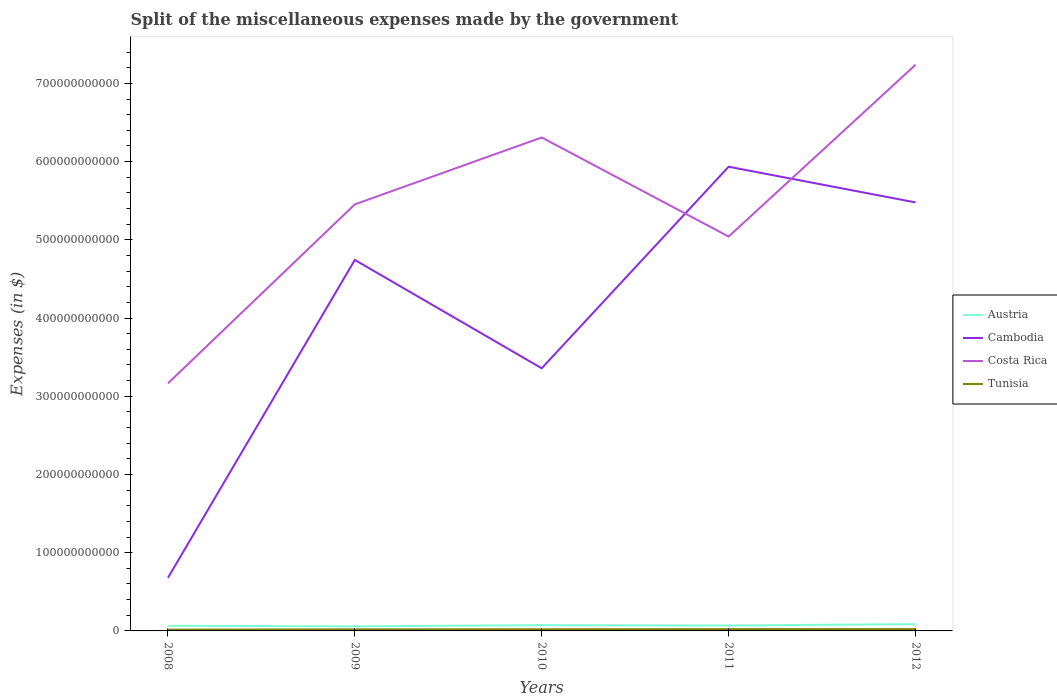Does the line corresponding to Austria intersect with the line corresponding to Tunisia?
Provide a succinct answer. No. Across all years, what is the maximum miscellaneous expenses made by the government in Costa Rica?
Ensure brevity in your answer.  3.16e+11. In which year was the miscellaneous expenses made by the government in Cambodia maximum?
Keep it short and to the point. 2008. What is the total miscellaneous expenses made by the government in Austria in the graph?
Make the answer very short. -4.32e+08. What is the difference between the highest and the second highest miscellaneous expenses made by the government in Tunisia?
Provide a short and direct response. 6.82e+08. What is the difference between the highest and the lowest miscellaneous expenses made by the government in Austria?
Provide a succinct answer. 2. How many lines are there?
Give a very brief answer. 4. How many years are there in the graph?
Give a very brief answer. 5. What is the difference between two consecutive major ticks on the Y-axis?
Your response must be concise. 1.00e+11. Does the graph contain any zero values?
Your response must be concise. No. How many legend labels are there?
Keep it short and to the point. 4. How are the legend labels stacked?
Give a very brief answer. Vertical. What is the title of the graph?
Offer a very short reply. Split of the miscellaneous expenses made by the government. What is the label or title of the Y-axis?
Your response must be concise. Expenses (in $). What is the Expenses (in $) of Austria in 2008?
Your response must be concise. 6.52e+09. What is the Expenses (in $) of Cambodia in 2008?
Make the answer very short. 6.78e+1. What is the Expenses (in $) of Costa Rica in 2008?
Offer a terse response. 3.16e+11. What is the Expenses (in $) of Tunisia in 2008?
Make the answer very short. 1.64e+09. What is the Expenses (in $) of Austria in 2009?
Ensure brevity in your answer.  5.87e+09. What is the Expenses (in $) of Cambodia in 2009?
Give a very brief answer. 4.74e+11. What is the Expenses (in $) in Costa Rica in 2009?
Make the answer very short. 5.45e+11. What is the Expenses (in $) of Tunisia in 2009?
Provide a succinct answer. 2.00e+09. What is the Expenses (in $) of Austria in 2010?
Your response must be concise. 7.39e+09. What is the Expenses (in $) of Cambodia in 2010?
Keep it short and to the point. 3.36e+11. What is the Expenses (in $) of Costa Rica in 2010?
Provide a succinct answer. 6.31e+11. What is the Expenses (in $) of Tunisia in 2010?
Make the answer very short. 2.07e+09. What is the Expenses (in $) in Austria in 2011?
Your answer should be compact. 6.96e+09. What is the Expenses (in $) in Cambodia in 2011?
Provide a succinct answer. 5.93e+11. What is the Expenses (in $) in Costa Rica in 2011?
Ensure brevity in your answer.  5.04e+11. What is the Expenses (in $) of Tunisia in 2011?
Your answer should be compact. 2.32e+09. What is the Expenses (in $) of Austria in 2012?
Make the answer very short. 8.69e+09. What is the Expenses (in $) of Cambodia in 2012?
Keep it short and to the point. 5.48e+11. What is the Expenses (in $) in Costa Rica in 2012?
Make the answer very short. 7.24e+11. What is the Expenses (in $) in Tunisia in 2012?
Offer a very short reply. 2.32e+09. Across all years, what is the maximum Expenses (in $) of Austria?
Ensure brevity in your answer.  8.69e+09. Across all years, what is the maximum Expenses (in $) in Cambodia?
Offer a terse response. 5.93e+11. Across all years, what is the maximum Expenses (in $) of Costa Rica?
Your answer should be compact. 7.24e+11. Across all years, what is the maximum Expenses (in $) in Tunisia?
Keep it short and to the point. 2.32e+09. Across all years, what is the minimum Expenses (in $) of Austria?
Provide a short and direct response. 5.87e+09. Across all years, what is the minimum Expenses (in $) in Cambodia?
Ensure brevity in your answer.  6.78e+1. Across all years, what is the minimum Expenses (in $) of Costa Rica?
Ensure brevity in your answer.  3.16e+11. Across all years, what is the minimum Expenses (in $) in Tunisia?
Ensure brevity in your answer.  1.64e+09. What is the total Expenses (in $) of Austria in the graph?
Your answer should be compact. 3.54e+1. What is the total Expenses (in $) in Cambodia in the graph?
Give a very brief answer. 2.02e+12. What is the total Expenses (in $) of Costa Rica in the graph?
Offer a terse response. 2.72e+12. What is the total Expenses (in $) in Tunisia in the graph?
Offer a terse response. 1.04e+1. What is the difference between the Expenses (in $) of Austria in 2008 and that in 2009?
Offer a terse response. 6.50e+08. What is the difference between the Expenses (in $) in Cambodia in 2008 and that in 2009?
Ensure brevity in your answer.  -4.06e+11. What is the difference between the Expenses (in $) in Costa Rica in 2008 and that in 2009?
Ensure brevity in your answer.  -2.29e+11. What is the difference between the Expenses (in $) of Tunisia in 2008 and that in 2009?
Your answer should be compact. -3.60e+08. What is the difference between the Expenses (in $) of Austria in 2008 and that in 2010?
Give a very brief answer. -8.63e+08. What is the difference between the Expenses (in $) in Cambodia in 2008 and that in 2010?
Your answer should be very brief. -2.68e+11. What is the difference between the Expenses (in $) in Costa Rica in 2008 and that in 2010?
Your response must be concise. -3.14e+11. What is the difference between the Expenses (in $) in Tunisia in 2008 and that in 2010?
Give a very brief answer. -4.31e+08. What is the difference between the Expenses (in $) in Austria in 2008 and that in 2011?
Give a very brief answer. -4.32e+08. What is the difference between the Expenses (in $) of Cambodia in 2008 and that in 2011?
Offer a very short reply. -5.26e+11. What is the difference between the Expenses (in $) in Costa Rica in 2008 and that in 2011?
Your answer should be very brief. -1.88e+11. What is the difference between the Expenses (in $) of Tunisia in 2008 and that in 2011?
Provide a succinct answer. -6.82e+08. What is the difference between the Expenses (in $) in Austria in 2008 and that in 2012?
Provide a succinct answer. -2.16e+09. What is the difference between the Expenses (in $) of Cambodia in 2008 and that in 2012?
Offer a terse response. -4.80e+11. What is the difference between the Expenses (in $) in Costa Rica in 2008 and that in 2012?
Ensure brevity in your answer.  -4.07e+11. What is the difference between the Expenses (in $) in Tunisia in 2008 and that in 2012?
Provide a succinct answer. -6.74e+08. What is the difference between the Expenses (in $) in Austria in 2009 and that in 2010?
Keep it short and to the point. -1.51e+09. What is the difference between the Expenses (in $) in Cambodia in 2009 and that in 2010?
Your answer should be compact. 1.38e+11. What is the difference between the Expenses (in $) of Costa Rica in 2009 and that in 2010?
Provide a short and direct response. -8.55e+1. What is the difference between the Expenses (in $) in Tunisia in 2009 and that in 2010?
Make the answer very short. -7.06e+07. What is the difference between the Expenses (in $) in Austria in 2009 and that in 2011?
Provide a short and direct response. -1.08e+09. What is the difference between the Expenses (in $) in Cambodia in 2009 and that in 2011?
Give a very brief answer. -1.19e+11. What is the difference between the Expenses (in $) in Costa Rica in 2009 and that in 2011?
Ensure brevity in your answer.  4.11e+1. What is the difference between the Expenses (in $) in Tunisia in 2009 and that in 2011?
Keep it short and to the point. -3.21e+08. What is the difference between the Expenses (in $) in Austria in 2009 and that in 2012?
Keep it short and to the point. -2.81e+09. What is the difference between the Expenses (in $) in Cambodia in 2009 and that in 2012?
Your answer should be compact. -7.35e+1. What is the difference between the Expenses (in $) of Costa Rica in 2009 and that in 2012?
Ensure brevity in your answer.  -1.78e+11. What is the difference between the Expenses (in $) of Tunisia in 2009 and that in 2012?
Keep it short and to the point. -3.14e+08. What is the difference between the Expenses (in $) in Austria in 2010 and that in 2011?
Your answer should be compact. 4.31e+08. What is the difference between the Expenses (in $) of Cambodia in 2010 and that in 2011?
Provide a succinct answer. -2.58e+11. What is the difference between the Expenses (in $) in Costa Rica in 2010 and that in 2011?
Give a very brief answer. 1.27e+11. What is the difference between the Expenses (in $) in Tunisia in 2010 and that in 2011?
Your answer should be very brief. -2.50e+08. What is the difference between the Expenses (in $) in Austria in 2010 and that in 2012?
Your answer should be very brief. -1.30e+09. What is the difference between the Expenses (in $) of Cambodia in 2010 and that in 2012?
Provide a succinct answer. -2.12e+11. What is the difference between the Expenses (in $) in Costa Rica in 2010 and that in 2012?
Your response must be concise. -9.29e+1. What is the difference between the Expenses (in $) in Tunisia in 2010 and that in 2012?
Your answer should be compact. -2.43e+08. What is the difference between the Expenses (in $) in Austria in 2011 and that in 2012?
Ensure brevity in your answer.  -1.73e+09. What is the difference between the Expenses (in $) of Cambodia in 2011 and that in 2012?
Your answer should be compact. 4.56e+1. What is the difference between the Expenses (in $) in Costa Rica in 2011 and that in 2012?
Make the answer very short. -2.20e+11. What is the difference between the Expenses (in $) in Tunisia in 2011 and that in 2012?
Offer a very short reply. 7.20e+06. What is the difference between the Expenses (in $) of Austria in 2008 and the Expenses (in $) of Cambodia in 2009?
Your answer should be very brief. -4.68e+11. What is the difference between the Expenses (in $) in Austria in 2008 and the Expenses (in $) in Costa Rica in 2009?
Offer a very short reply. -5.39e+11. What is the difference between the Expenses (in $) in Austria in 2008 and the Expenses (in $) in Tunisia in 2009?
Your answer should be very brief. 4.52e+09. What is the difference between the Expenses (in $) in Cambodia in 2008 and the Expenses (in $) in Costa Rica in 2009?
Your answer should be very brief. -4.78e+11. What is the difference between the Expenses (in $) in Cambodia in 2008 and the Expenses (in $) in Tunisia in 2009?
Offer a very short reply. 6.58e+1. What is the difference between the Expenses (in $) in Costa Rica in 2008 and the Expenses (in $) in Tunisia in 2009?
Give a very brief answer. 3.14e+11. What is the difference between the Expenses (in $) of Austria in 2008 and the Expenses (in $) of Cambodia in 2010?
Provide a short and direct response. -3.29e+11. What is the difference between the Expenses (in $) in Austria in 2008 and the Expenses (in $) in Costa Rica in 2010?
Your answer should be compact. -6.24e+11. What is the difference between the Expenses (in $) of Austria in 2008 and the Expenses (in $) of Tunisia in 2010?
Offer a very short reply. 4.45e+09. What is the difference between the Expenses (in $) of Cambodia in 2008 and the Expenses (in $) of Costa Rica in 2010?
Offer a very short reply. -5.63e+11. What is the difference between the Expenses (in $) of Cambodia in 2008 and the Expenses (in $) of Tunisia in 2010?
Provide a short and direct response. 6.58e+1. What is the difference between the Expenses (in $) of Costa Rica in 2008 and the Expenses (in $) of Tunisia in 2010?
Provide a succinct answer. 3.14e+11. What is the difference between the Expenses (in $) of Austria in 2008 and the Expenses (in $) of Cambodia in 2011?
Provide a succinct answer. -5.87e+11. What is the difference between the Expenses (in $) of Austria in 2008 and the Expenses (in $) of Costa Rica in 2011?
Ensure brevity in your answer.  -4.98e+11. What is the difference between the Expenses (in $) in Austria in 2008 and the Expenses (in $) in Tunisia in 2011?
Your response must be concise. 4.20e+09. What is the difference between the Expenses (in $) in Cambodia in 2008 and the Expenses (in $) in Costa Rica in 2011?
Ensure brevity in your answer.  -4.36e+11. What is the difference between the Expenses (in $) of Cambodia in 2008 and the Expenses (in $) of Tunisia in 2011?
Offer a very short reply. 6.55e+1. What is the difference between the Expenses (in $) of Costa Rica in 2008 and the Expenses (in $) of Tunisia in 2011?
Your answer should be compact. 3.14e+11. What is the difference between the Expenses (in $) of Austria in 2008 and the Expenses (in $) of Cambodia in 2012?
Your answer should be compact. -5.41e+11. What is the difference between the Expenses (in $) of Austria in 2008 and the Expenses (in $) of Costa Rica in 2012?
Offer a terse response. -7.17e+11. What is the difference between the Expenses (in $) in Austria in 2008 and the Expenses (in $) in Tunisia in 2012?
Keep it short and to the point. 4.21e+09. What is the difference between the Expenses (in $) of Cambodia in 2008 and the Expenses (in $) of Costa Rica in 2012?
Keep it short and to the point. -6.56e+11. What is the difference between the Expenses (in $) in Cambodia in 2008 and the Expenses (in $) in Tunisia in 2012?
Provide a short and direct response. 6.55e+1. What is the difference between the Expenses (in $) of Costa Rica in 2008 and the Expenses (in $) of Tunisia in 2012?
Provide a short and direct response. 3.14e+11. What is the difference between the Expenses (in $) in Austria in 2009 and the Expenses (in $) in Cambodia in 2010?
Your answer should be compact. -3.30e+11. What is the difference between the Expenses (in $) of Austria in 2009 and the Expenses (in $) of Costa Rica in 2010?
Your answer should be compact. -6.25e+11. What is the difference between the Expenses (in $) in Austria in 2009 and the Expenses (in $) in Tunisia in 2010?
Your answer should be very brief. 3.80e+09. What is the difference between the Expenses (in $) of Cambodia in 2009 and the Expenses (in $) of Costa Rica in 2010?
Offer a very short reply. -1.57e+11. What is the difference between the Expenses (in $) in Cambodia in 2009 and the Expenses (in $) in Tunisia in 2010?
Your answer should be compact. 4.72e+11. What is the difference between the Expenses (in $) in Costa Rica in 2009 and the Expenses (in $) in Tunisia in 2010?
Keep it short and to the point. 5.43e+11. What is the difference between the Expenses (in $) of Austria in 2009 and the Expenses (in $) of Cambodia in 2011?
Provide a short and direct response. -5.88e+11. What is the difference between the Expenses (in $) in Austria in 2009 and the Expenses (in $) in Costa Rica in 2011?
Your answer should be very brief. -4.98e+11. What is the difference between the Expenses (in $) in Austria in 2009 and the Expenses (in $) in Tunisia in 2011?
Offer a very short reply. 3.55e+09. What is the difference between the Expenses (in $) in Cambodia in 2009 and the Expenses (in $) in Costa Rica in 2011?
Make the answer very short. -2.99e+1. What is the difference between the Expenses (in $) of Cambodia in 2009 and the Expenses (in $) of Tunisia in 2011?
Make the answer very short. 4.72e+11. What is the difference between the Expenses (in $) in Costa Rica in 2009 and the Expenses (in $) in Tunisia in 2011?
Provide a succinct answer. 5.43e+11. What is the difference between the Expenses (in $) in Austria in 2009 and the Expenses (in $) in Cambodia in 2012?
Provide a succinct answer. -5.42e+11. What is the difference between the Expenses (in $) of Austria in 2009 and the Expenses (in $) of Costa Rica in 2012?
Ensure brevity in your answer.  -7.18e+11. What is the difference between the Expenses (in $) in Austria in 2009 and the Expenses (in $) in Tunisia in 2012?
Keep it short and to the point. 3.56e+09. What is the difference between the Expenses (in $) in Cambodia in 2009 and the Expenses (in $) in Costa Rica in 2012?
Give a very brief answer. -2.49e+11. What is the difference between the Expenses (in $) of Cambodia in 2009 and the Expenses (in $) of Tunisia in 2012?
Your answer should be very brief. 4.72e+11. What is the difference between the Expenses (in $) of Costa Rica in 2009 and the Expenses (in $) of Tunisia in 2012?
Your response must be concise. 5.43e+11. What is the difference between the Expenses (in $) of Austria in 2010 and the Expenses (in $) of Cambodia in 2011?
Your response must be concise. -5.86e+11. What is the difference between the Expenses (in $) of Austria in 2010 and the Expenses (in $) of Costa Rica in 2011?
Offer a very short reply. -4.97e+11. What is the difference between the Expenses (in $) in Austria in 2010 and the Expenses (in $) in Tunisia in 2011?
Your answer should be very brief. 5.06e+09. What is the difference between the Expenses (in $) of Cambodia in 2010 and the Expenses (in $) of Costa Rica in 2011?
Your answer should be very brief. -1.68e+11. What is the difference between the Expenses (in $) of Cambodia in 2010 and the Expenses (in $) of Tunisia in 2011?
Provide a succinct answer. 3.33e+11. What is the difference between the Expenses (in $) of Costa Rica in 2010 and the Expenses (in $) of Tunisia in 2011?
Your response must be concise. 6.29e+11. What is the difference between the Expenses (in $) of Austria in 2010 and the Expenses (in $) of Cambodia in 2012?
Provide a succinct answer. -5.40e+11. What is the difference between the Expenses (in $) of Austria in 2010 and the Expenses (in $) of Costa Rica in 2012?
Your answer should be very brief. -7.16e+11. What is the difference between the Expenses (in $) of Austria in 2010 and the Expenses (in $) of Tunisia in 2012?
Your answer should be very brief. 5.07e+09. What is the difference between the Expenses (in $) of Cambodia in 2010 and the Expenses (in $) of Costa Rica in 2012?
Provide a short and direct response. -3.88e+11. What is the difference between the Expenses (in $) in Cambodia in 2010 and the Expenses (in $) in Tunisia in 2012?
Give a very brief answer. 3.33e+11. What is the difference between the Expenses (in $) in Costa Rica in 2010 and the Expenses (in $) in Tunisia in 2012?
Offer a terse response. 6.29e+11. What is the difference between the Expenses (in $) in Austria in 2011 and the Expenses (in $) in Cambodia in 2012?
Provide a short and direct response. -5.41e+11. What is the difference between the Expenses (in $) in Austria in 2011 and the Expenses (in $) in Costa Rica in 2012?
Keep it short and to the point. -7.17e+11. What is the difference between the Expenses (in $) of Austria in 2011 and the Expenses (in $) of Tunisia in 2012?
Provide a short and direct response. 4.64e+09. What is the difference between the Expenses (in $) in Cambodia in 2011 and the Expenses (in $) in Costa Rica in 2012?
Give a very brief answer. -1.30e+11. What is the difference between the Expenses (in $) in Cambodia in 2011 and the Expenses (in $) in Tunisia in 2012?
Your answer should be compact. 5.91e+11. What is the difference between the Expenses (in $) in Costa Rica in 2011 and the Expenses (in $) in Tunisia in 2012?
Your response must be concise. 5.02e+11. What is the average Expenses (in $) in Austria per year?
Offer a very short reply. 7.08e+09. What is the average Expenses (in $) in Cambodia per year?
Provide a short and direct response. 4.04e+11. What is the average Expenses (in $) in Costa Rica per year?
Your response must be concise. 5.44e+11. What is the average Expenses (in $) in Tunisia per year?
Keep it short and to the point. 2.07e+09. In the year 2008, what is the difference between the Expenses (in $) of Austria and Expenses (in $) of Cambodia?
Your response must be concise. -6.13e+1. In the year 2008, what is the difference between the Expenses (in $) in Austria and Expenses (in $) in Costa Rica?
Provide a succinct answer. -3.10e+11. In the year 2008, what is the difference between the Expenses (in $) in Austria and Expenses (in $) in Tunisia?
Offer a very short reply. 4.88e+09. In the year 2008, what is the difference between the Expenses (in $) of Cambodia and Expenses (in $) of Costa Rica?
Give a very brief answer. -2.49e+11. In the year 2008, what is the difference between the Expenses (in $) of Cambodia and Expenses (in $) of Tunisia?
Ensure brevity in your answer.  6.62e+1. In the year 2008, what is the difference between the Expenses (in $) in Costa Rica and Expenses (in $) in Tunisia?
Offer a terse response. 3.15e+11. In the year 2009, what is the difference between the Expenses (in $) in Austria and Expenses (in $) in Cambodia?
Offer a terse response. -4.68e+11. In the year 2009, what is the difference between the Expenses (in $) of Austria and Expenses (in $) of Costa Rica?
Offer a very short reply. -5.39e+11. In the year 2009, what is the difference between the Expenses (in $) in Austria and Expenses (in $) in Tunisia?
Your answer should be compact. 3.87e+09. In the year 2009, what is the difference between the Expenses (in $) in Cambodia and Expenses (in $) in Costa Rica?
Make the answer very short. -7.11e+1. In the year 2009, what is the difference between the Expenses (in $) in Cambodia and Expenses (in $) in Tunisia?
Your response must be concise. 4.72e+11. In the year 2009, what is the difference between the Expenses (in $) in Costa Rica and Expenses (in $) in Tunisia?
Your response must be concise. 5.43e+11. In the year 2010, what is the difference between the Expenses (in $) in Austria and Expenses (in $) in Cambodia?
Make the answer very short. -3.28e+11. In the year 2010, what is the difference between the Expenses (in $) in Austria and Expenses (in $) in Costa Rica?
Give a very brief answer. -6.23e+11. In the year 2010, what is the difference between the Expenses (in $) in Austria and Expenses (in $) in Tunisia?
Keep it short and to the point. 5.31e+09. In the year 2010, what is the difference between the Expenses (in $) in Cambodia and Expenses (in $) in Costa Rica?
Your answer should be compact. -2.95e+11. In the year 2010, what is the difference between the Expenses (in $) in Cambodia and Expenses (in $) in Tunisia?
Ensure brevity in your answer.  3.34e+11. In the year 2010, what is the difference between the Expenses (in $) of Costa Rica and Expenses (in $) of Tunisia?
Give a very brief answer. 6.29e+11. In the year 2011, what is the difference between the Expenses (in $) of Austria and Expenses (in $) of Cambodia?
Offer a very short reply. -5.87e+11. In the year 2011, what is the difference between the Expenses (in $) of Austria and Expenses (in $) of Costa Rica?
Offer a terse response. -4.97e+11. In the year 2011, what is the difference between the Expenses (in $) of Austria and Expenses (in $) of Tunisia?
Provide a short and direct response. 4.63e+09. In the year 2011, what is the difference between the Expenses (in $) of Cambodia and Expenses (in $) of Costa Rica?
Offer a terse response. 8.93e+1. In the year 2011, what is the difference between the Expenses (in $) of Cambodia and Expenses (in $) of Tunisia?
Your answer should be compact. 5.91e+11. In the year 2011, what is the difference between the Expenses (in $) in Costa Rica and Expenses (in $) in Tunisia?
Give a very brief answer. 5.02e+11. In the year 2012, what is the difference between the Expenses (in $) in Austria and Expenses (in $) in Cambodia?
Offer a very short reply. -5.39e+11. In the year 2012, what is the difference between the Expenses (in $) of Austria and Expenses (in $) of Costa Rica?
Offer a very short reply. -7.15e+11. In the year 2012, what is the difference between the Expenses (in $) in Austria and Expenses (in $) in Tunisia?
Your response must be concise. 6.37e+09. In the year 2012, what is the difference between the Expenses (in $) in Cambodia and Expenses (in $) in Costa Rica?
Your response must be concise. -1.76e+11. In the year 2012, what is the difference between the Expenses (in $) of Cambodia and Expenses (in $) of Tunisia?
Your answer should be compact. 5.46e+11. In the year 2012, what is the difference between the Expenses (in $) in Costa Rica and Expenses (in $) in Tunisia?
Your answer should be compact. 7.21e+11. What is the ratio of the Expenses (in $) in Austria in 2008 to that in 2009?
Offer a very short reply. 1.11. What is the ratio of the Expenses (in $) of Cambodia in 2008 to that in 2009?
Make the answer very short. 0.14. What is the ratio of the Expenses (in $) in Costa Rica in 2008 to that in 2009?
Offer a very short reply. 0.58. What is the ratio of the Expenses (in $) in Tunisia in 2008 to that in 2009?
Your answer should be compact. 0.82. What is the ratio of the Expenses (in $) in Austria in 2008 to that in 2010?
Give a very brief answer. 0.88. What is the ratio of the Expenses (in $) of Cambodia in 2008 to that in 2010?
Provide a short and direct response. 0.2. What is the ratio of the Expenses (in $) in Costa Rica in 2008 to that in 2010?
Keep it short and to the point. 0.5. What is the ratio of the Expenses (in $) in Tunisia in 2008 to that in 2010?
Provide a succinct answer. 0.79. What is the ratio of the Expenses (in $) of Austria in 2008 to that in 2011?
Your answer should be very brief. 0.94. What is the ratio of the Expenses (in $) of Cambodia in 2008 to that in 2011?
Give a very brief answer. 0.11. What is the ratio of the Expenses (in $) in Costa Rica in 2008 to that in 2011?
Make the answer very short. 0.63. What is the ratio of the Expenses (in $) in Tunisia in 2008 to that in 2011?
Provide a succinct answer. 0.71. What is the ratio of the Expenses (in $) in Austria in 2008 to that in 2012?
Offer a terse response. 0.75. What is the ratio of the Expenses (in $) in Cambodia in 2008 to that in 2012?
Keep it short and to the point. 0.12. What is the ratio of the Expenses (in $) in Costa Rica in 2008 to that in 2012?
Your answer should be compact. 0.44. What is the ratio of the Expenses (in $) of Tunisia in 2008 to that in 2012?
Keep it short and to the point. 0.71. What is the ratio of the Expenses (in $) of Austria in 2009 to that in 2010?
Provide a short and direct response. 0.8. What is the ratio of the Expenses (in $) of Cambodia in 2009 to that in 2010?
Your response must be concise. 1.41. What is the ratio of the Expenses (in $) of Costa Rica in 2009 to that in 2010?
Give a very brief answer. 0.86. What is the ratio of the Expenses (in $) of Tunisia in 2009 to that in 2010?
Offer a terse response. 0.97. What is the ratio of the Expenses (in $) in Austria in 2009 to that in 2011?
Offer a very short reply. 0.84. What is the ratio of the Expenses (in $) of Cambodia in 2009 to that in 2011?
Your answer should be very brief. 0.8. What is the ratio of the Expenses (in $) in Costa Rica in 2009 to that in 2011?
Offer a terse response. 1.08. What is the ratio of the Expenses (in $) in Tunisia in 2009 to that in 2011?
Offer a terse response. 0.86. What is the ratio of the Expenses (in $) of Austria in 2009 to that in 2012?
Give a very brief answer. 0.68. What is the ratio of the Expenses (in $) in Cambodia in 2009 to that in 2012?
Keep it short and to the point. 0.87. What is the ratio of the Expenses (in $) of Costa Rica in 2009 to that in 2012?
Provide a short and direct response. 0.75. What is the ratio of the Expenses (in $) of Tunisia in 2009 to that in 2012?
Provide a short and direct response. 0.86. What is the ratio of the Expenses (in $) of Austria in 2010 to that in 2011?
Your response must be concise. 1.06. What is the ratio of the Expenses (in $) in Cambodia in 2010 to that in 2011?
Make the answer very short. 0.57. What is the ratio of the Expenses (in $) of Costa Rica in 2010 to that in 2011?
Keep it short and to the point. 1.25. What is the ratio of the Expenses (in $) in Tunisia in 2010 to that in 2011?
Make the answer very short. 0.89. What is the ratio of the Expenses (in $) of Austria in 2010 to that in 2012?
Keep it short and to the point. 0.85. What is the ratio of the Expenses (in $) of Cambodia in 2010 to that in 2012?
Offer a terse response. 0.61. What is the ratio of the Expenses (in $) in Costa Rica in 2010 to that in 2012?
Provide a short and direct response. 0.87. What is the ratio of the Expenses (in $) of Tunisia in 2010 to that in 2012?
Your answer should be very brief. 0.9. What is the ratio of the Expenses (in $) in Austria in 2011 to that in 2012?
Provide a succinct answer. 0.8. What is the ratio of the Expenses (in $) of Cambodia in 2011 to that in 2012?
Provide a short and direct response. 1.08. What is the ratio of the Expenses (in $) in Costa Rica in 2011 to that in 2012?
Offer a very short reply. 0.7. What is the ratio of the Expenses (in $) of Tunisia in 2011 to that in 2012?
Your answer should be very brief. 1. What is the difference between the highest and the second highest Expenses (in $) in Austria?
Offer a very short reply. 1.30e+09. What is the difference between the highest and the second highest Expenses (in $) of Cambodia?
Offer a very short reply. 4.56e+1. What is the difference between the highest and the second highest Expenses (in $) of Costa Rica?
Your answer should be compact. 9.29e+1. What is the difference between the highest and the second highest Expenses (in $) in Tunisia?
Provide a succinct answer. 7.20e+06. What is the difference between the highest and the lowest Expenses (in $) in Austria?
Your answer should be very brief. 2.81e+09. What is the difference between the highest and the lowest Expenses (in $) in Cambodia?
Your answer should be very brief. 5.26e+11. What is the difference between the highest and the lowest Expenses (in $) of Costa Rica?
Offer a very short reply. 4.07e+11. What is the difference between the highest and the lowest Expenses (in $) of Tunisia?
Ensure brevity in your answer.  6.82e+08. 